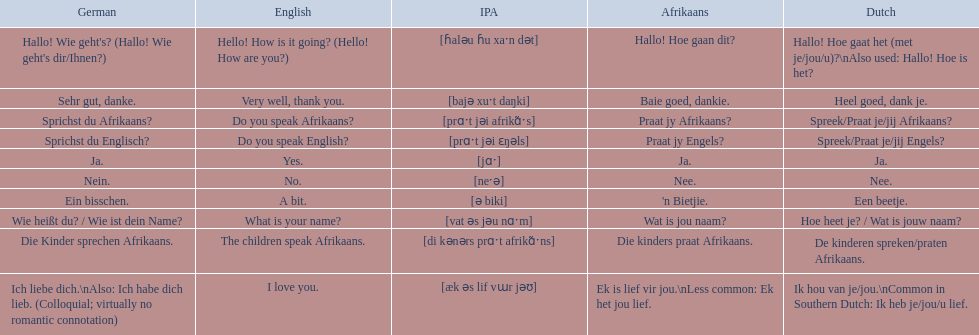How would you say the phrase the children speak afrikaans in afrikaans? Die kinders praat Afrikaans. How would you say the previous phrase in german? Die Kinder sprechen Afrikaans. 